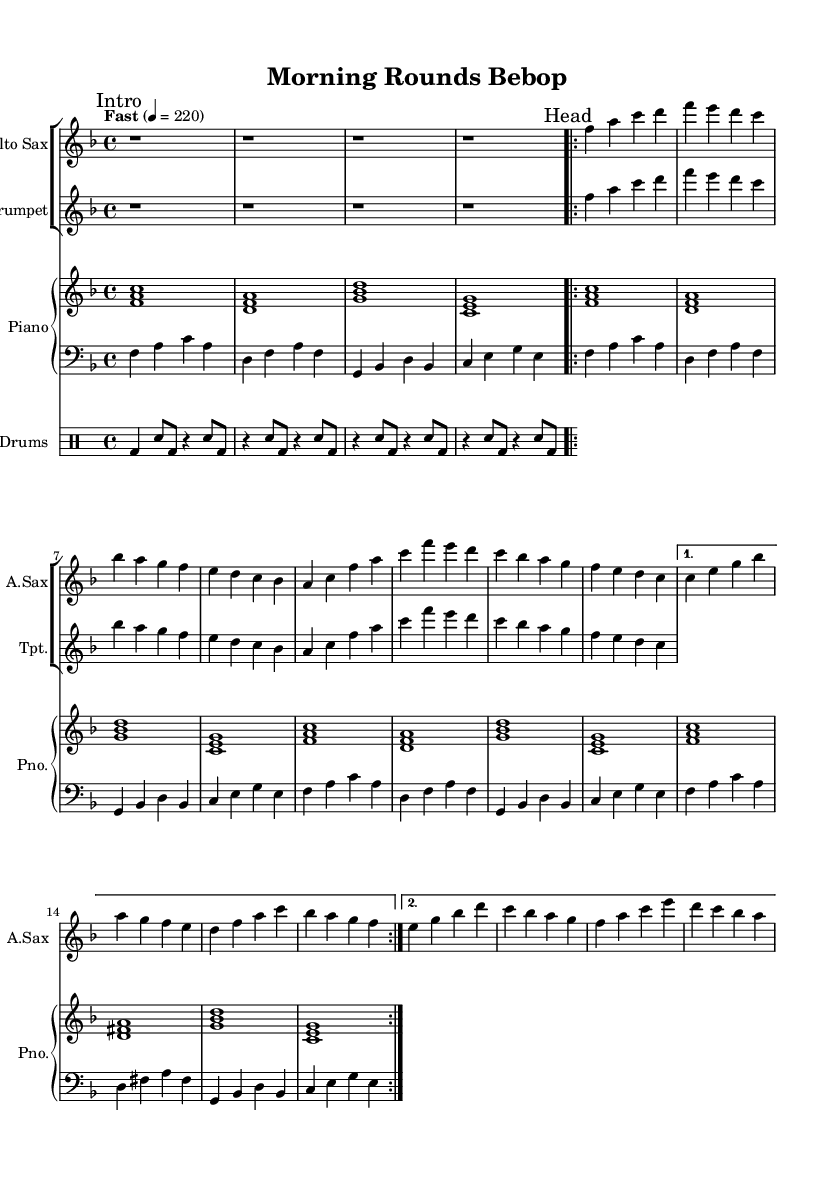What is the key signature of this music? The key signature is F major, which has one flat (B flat). This can be determined by looking at the key signature indicated in the first staff of the sheet music.
Answer: F major What is the time signature of this piece? The time signature is 4/4, which indicates that there are four beats in each measure and that the quarter note receives one beat. This is visible in the top left corner of the first staff.
Answer: 4/4 What is the tempo marking for this piece? The tempo marking indicates "Fast" at a speed of 220 beats per minute. This is shown at the beginning of the score where the tempo is specified.
Answer: Fast 220 How many times is the “Head” section repeated? The "Head" section is repeated twice, as indicated by the volta markings in the sheet music, specifically shown after the “Head” statement.
Answer: 2 What is the final chord in the piano part? The final chord in the piano part is a C major chord. This is identified by the notes C, E, and G, which are the notes played in the last measure of the piano part.
Answer: C major What type of music is represented by this piece? The piece can be classified as bebop jazz, which is evident from the fast tempo, complex melodies, and the instrumental voicing typical of jazz ensembles. This is inferred based on the overall style and arrangement of the music presented.
Answer: Bebop jazz What instruments are featured in this piece? The instruments featured are the Alto Saxophone, Trumpet, Piano, Bass, and Drums. These are listed at the beginning of each corresponding staff.
Answer: Alto Saxophone, Trumpet, Piano, Bass, Drums 